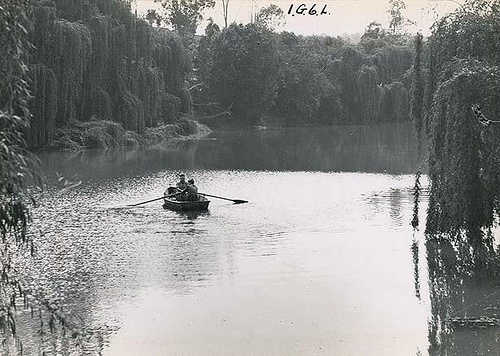Describe the objects in this image and their specific colors. I can see boat in gray, black, darkgray, and lightgray tones, people in gray, black, and darkgray tones, and people in gray, black, darkgray, and lightgray tones in this image. 